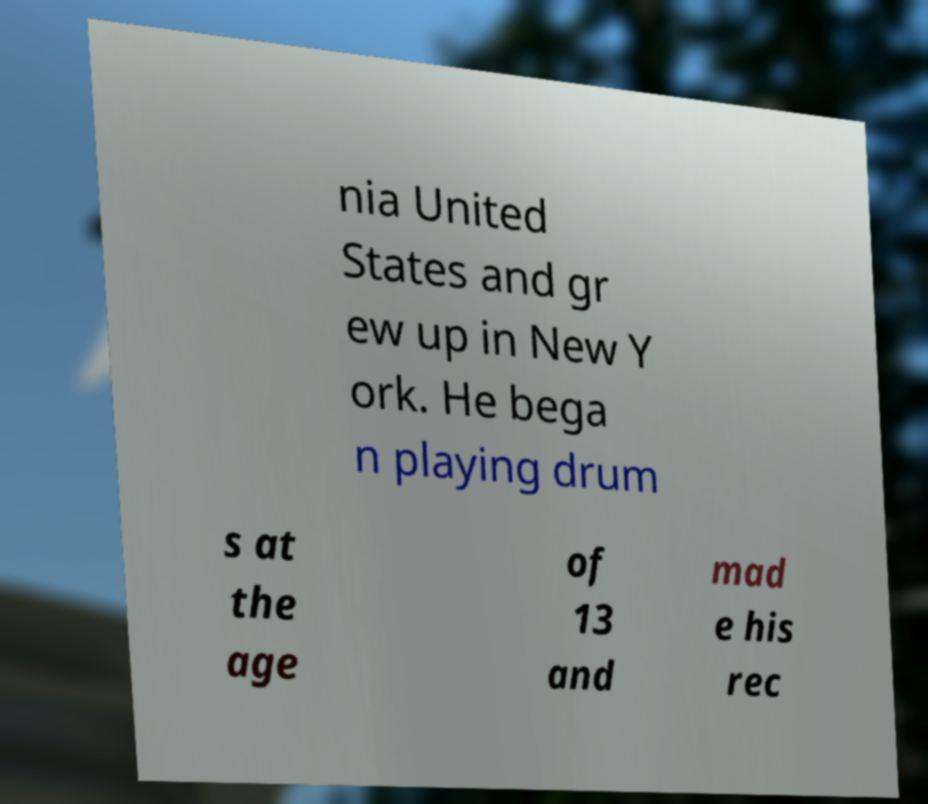Could you assist in decoding the text presented in this image and type it out clearly? nia United States and gr ew up in New Y ork. He bega n playing drum s at the age of 13 and mad e his rec 